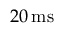Convert formula to latex. <formula><loc_0><loc_0><loc_500><loc_500>2 0 \, m s</formula> 